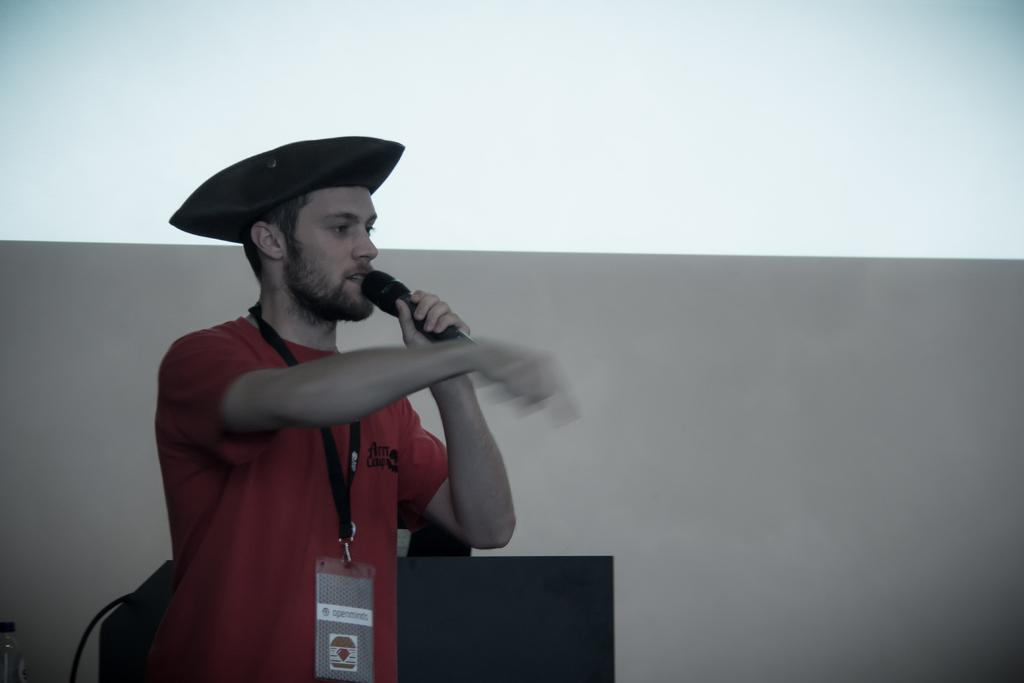What is the main subject of the image? There is a person in the image. What is the person doing in the image? The person is standing and holding a microphone. What is the person wearing on their head? The person is wearing a cap. What object can be seen near the person in the image? There is a podium in the image. How many chickens are visible on the podium in the image? There are no chickens present in the image; the person is holding a microphone and standing near a podium. 